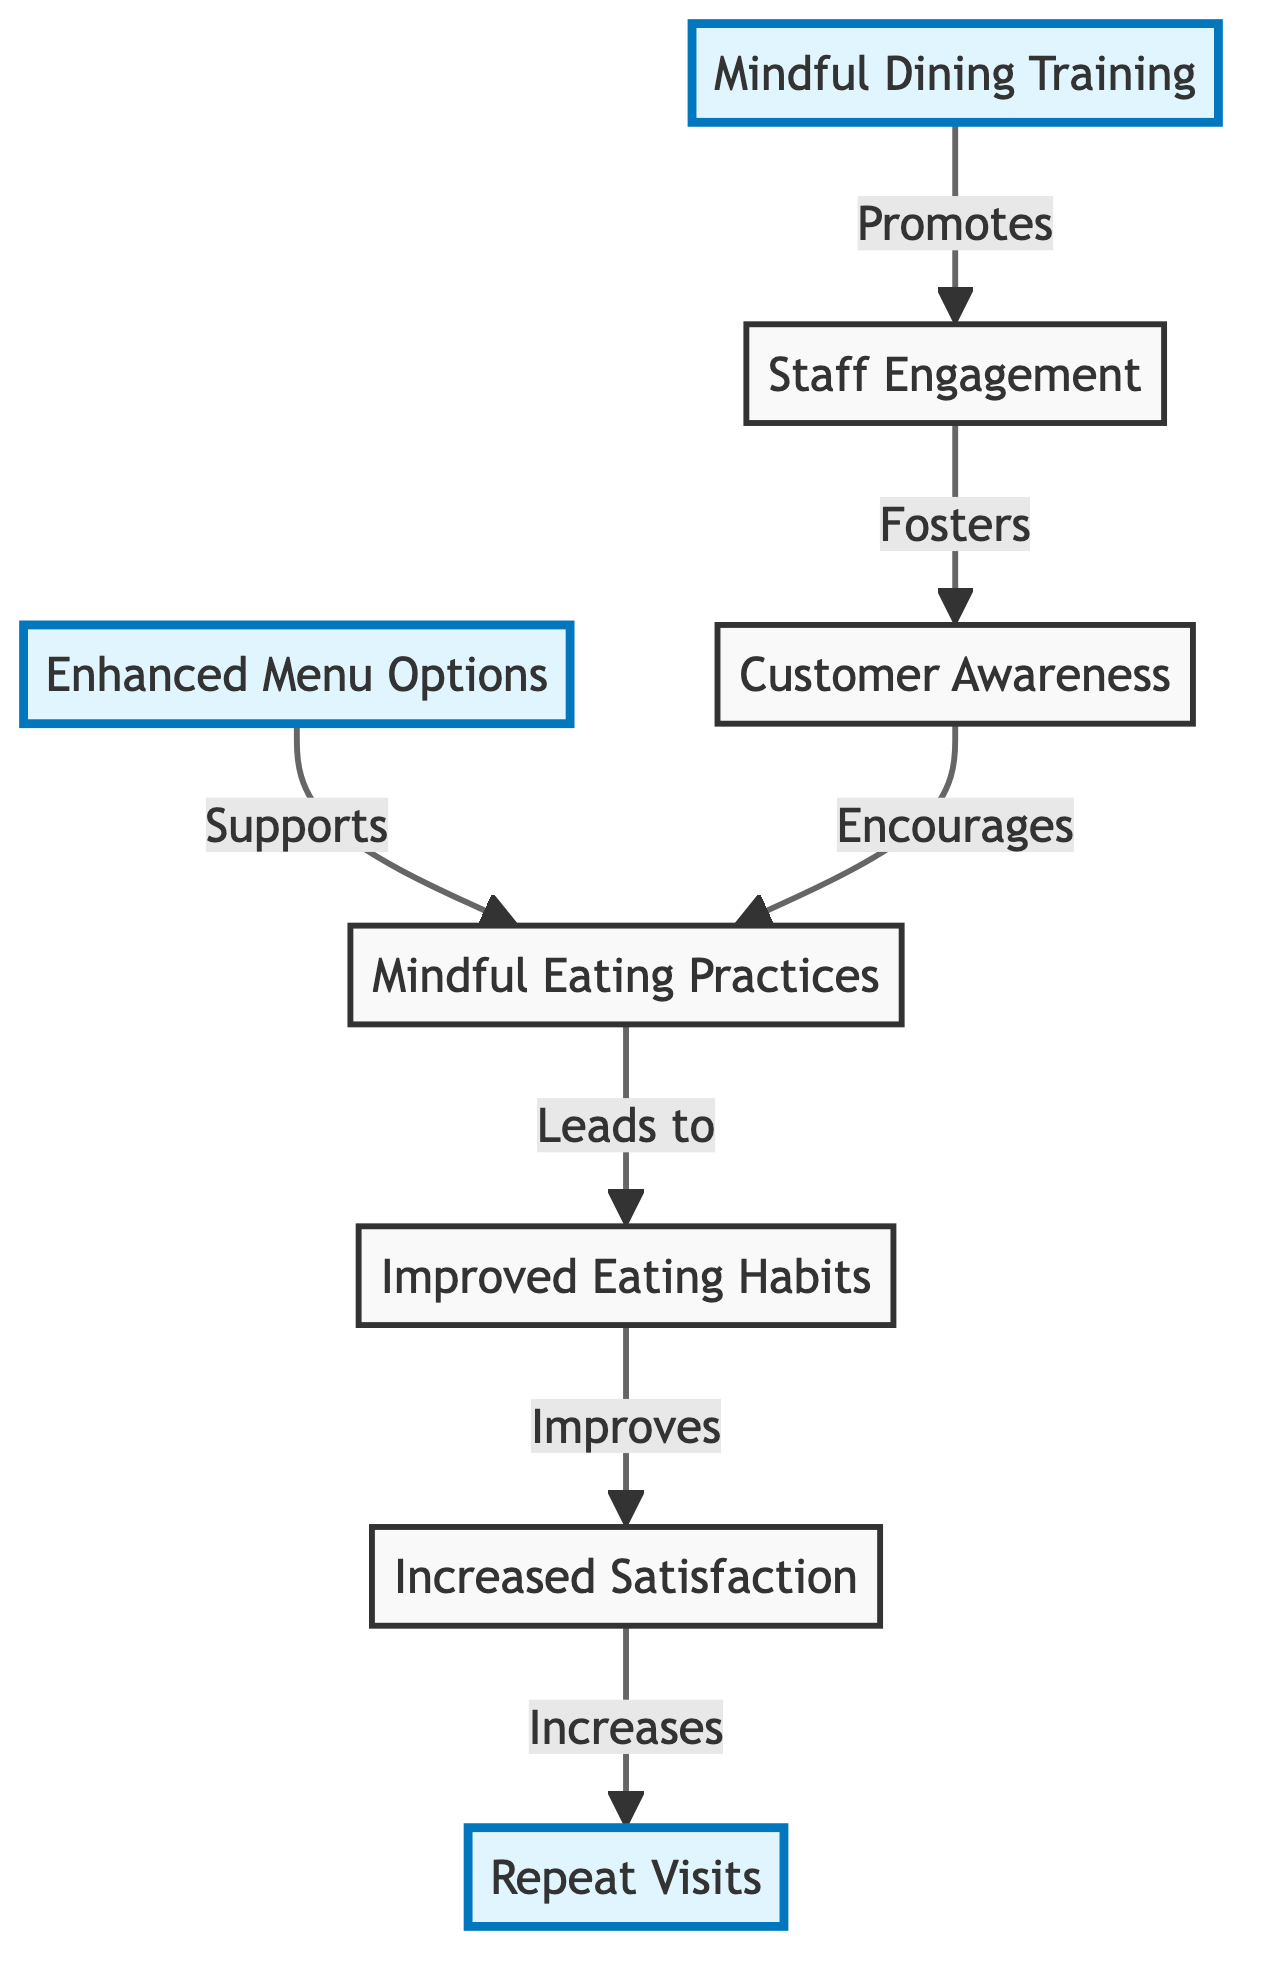What are the two highlighted nodes in the diagram? The highlighted nodes are specifically indicated in the diagram; scanning for the nodes with the highlight class, we find "Mindful Dining Training" and "Enhanced Menu Options," and also "Repeat Visits" as another highlighted node.
Answer: Mindful Dining Training, Enhanced Menu Options, Repeat Visits What relationship does staff engagement have with customer awareness? According to the diagram's flow, "Staff Engagement" connects to "Customer Awareness" with the label "Fosters," indicating that staff engagement plays a role in creating customer awareness.
Answer: Fosters How many main nodes are present in the diagram? By counting the distinct labeled nodes in the diagram, we identify a total of 7 main nodes, which include the highlighted nodes as well.
Answer: 7 What input leads to improved eating habits? The diagram shows that both "Mindful Eating Practices" and "Customer Awareness" are essential inputs that lead to "Improved Eating Habits," showing a connection through these nodes.
Answer: Mindful Eating Practices, Customer Awareness What is the final outcome of increased customer satisfaction as per the diagram? The diagram reveals that "Increased Satisfaction" leads directly to "Repeat Visits," indicating that higher satisfaction improves the likelihood of customers returning.
Answer: Repeat Visits What influences customer awareness according to the diagram? In the diagram, "Staff Engagement" is indicated to have a relationship with "Customer Awareness." Furthermore, "Enhanced Menu Options" supports the development of Mindful Eating Practices which also encourages customer awareness. Thus, the influences come from both staff engagement and menu options.
Answer: Staff Engagement, Enhanced Menu Options Which node follows enhanced menu options in the flow of the diagram? By examining the sequence of connections, we see that "Enhanced Menu Options" supports "Mindful Eating Practices," indicating it is directly followed by that node.
Answer: Mindful Eating Practices 